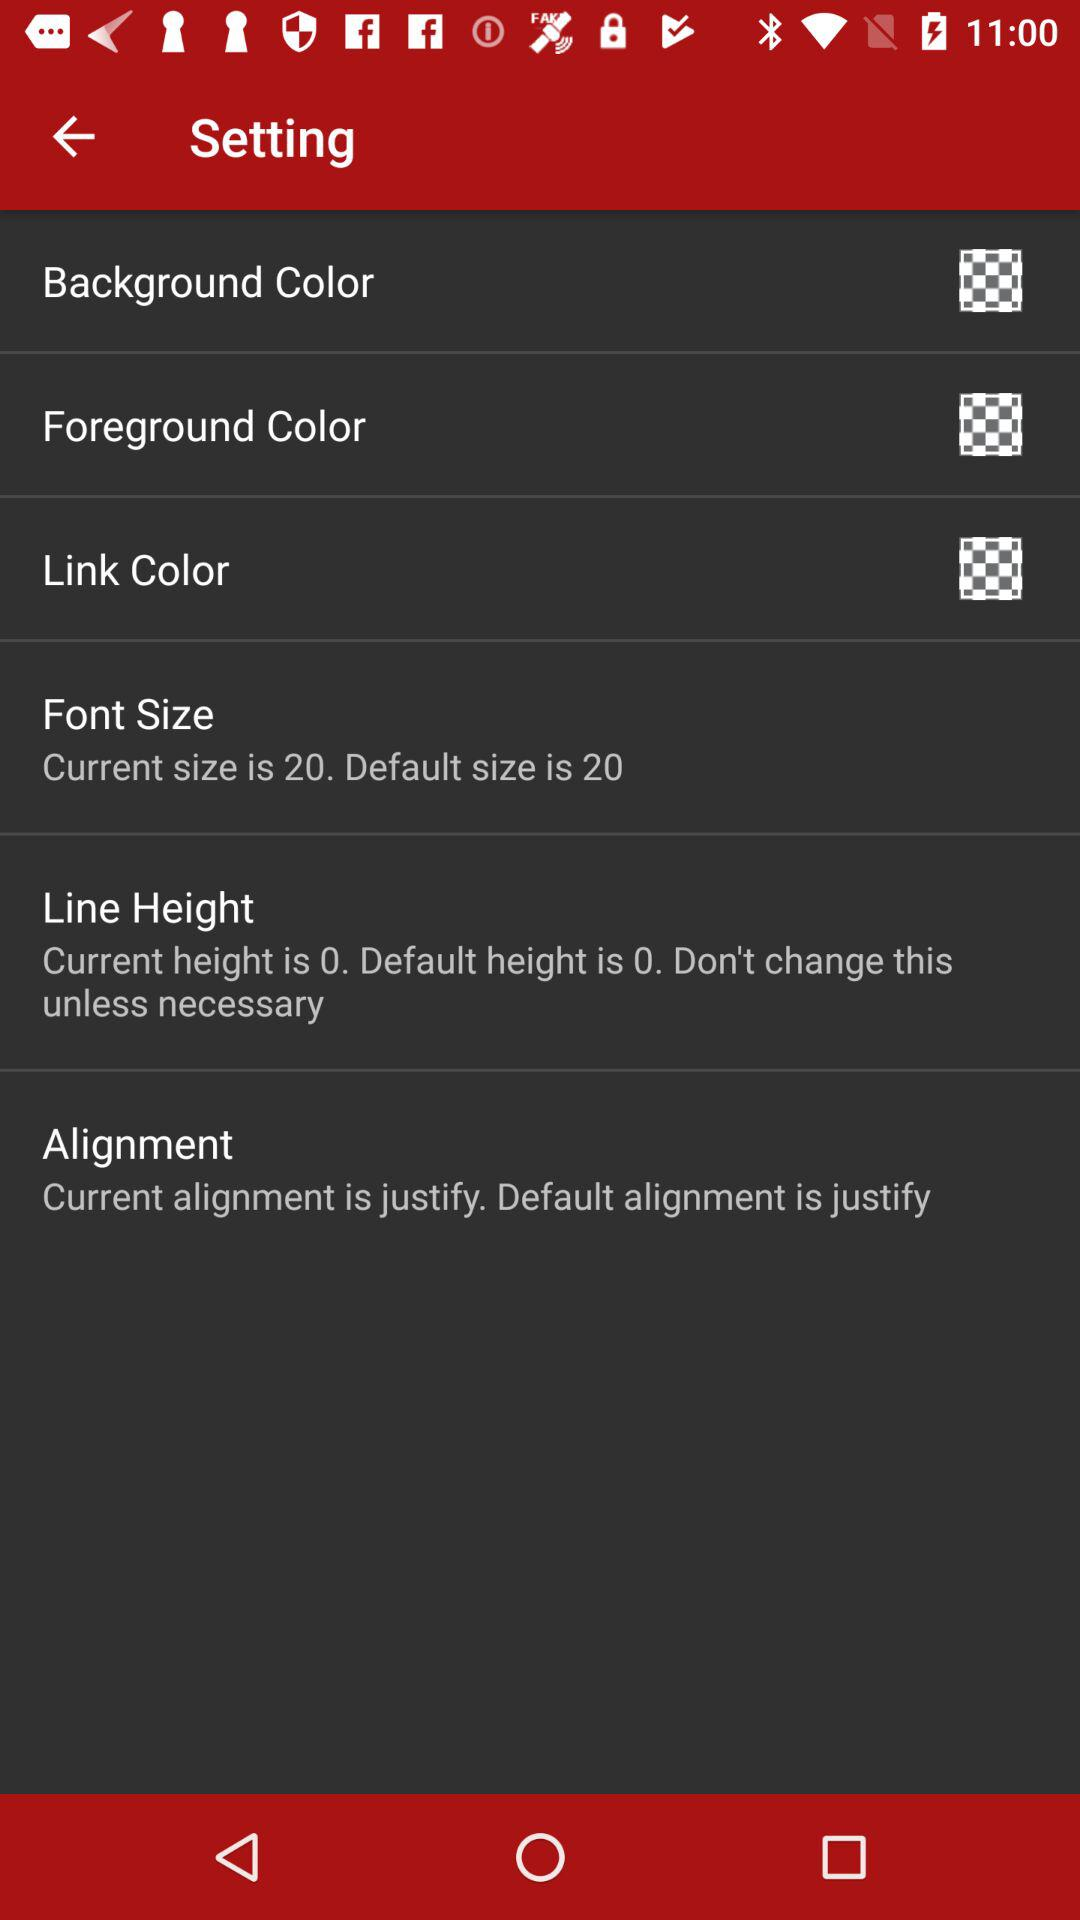What is the difference between the current and default font sizes?
Answer the question using a single word or phrase. 0 